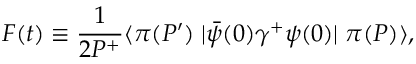Convert formula to latex. <formula><loc_0><loc_0><loc_500><loc_500>F ( t ) \equiv \frac { 1 } { 2 P ^ { + } } \langle \pi ( P ^ { \prime } ) \, | \bar { \psi } ( 0 ) \gamma ^ { + } \psi ( 0 ) | \, \pi ( P ) \rangle ,</formula> 